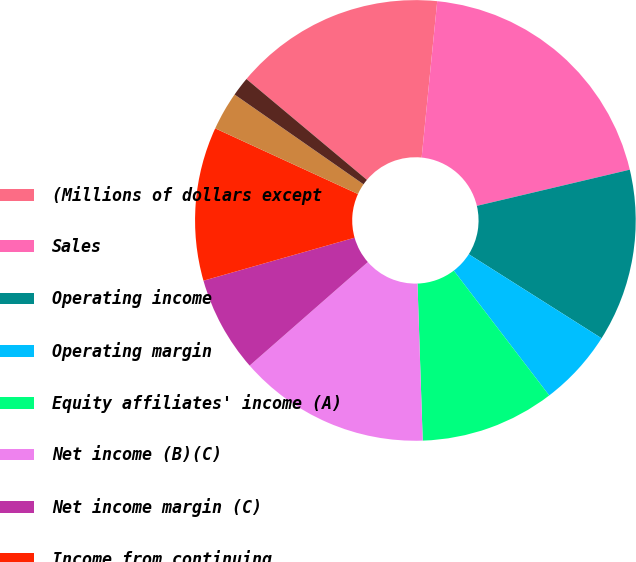Convert chart to OTSL. <chart><loc_0><loc_0><loc_500><loc_500><pie_chart><fcel>(Millions of dollars except<fcel>Sales<fcel>Operating income<fcel>Operating margin<fcel>Equity affiliates' income (A)<fcel>Net income (B)(C)<fcel>Net income margin (C)<fcel>Income from continuing<fcel>Basic earnings per common<fcel>Diluted earnings per common<nl><fcel>15.49%<fcel>19.72%<fcel>12.68%<fcel>5.63%<fcel>9.86%<fcel>14.08%<fcel>7.04%<fcel>11.27%<fcel>2.82%<fcel>1.41%<nl></chart> 